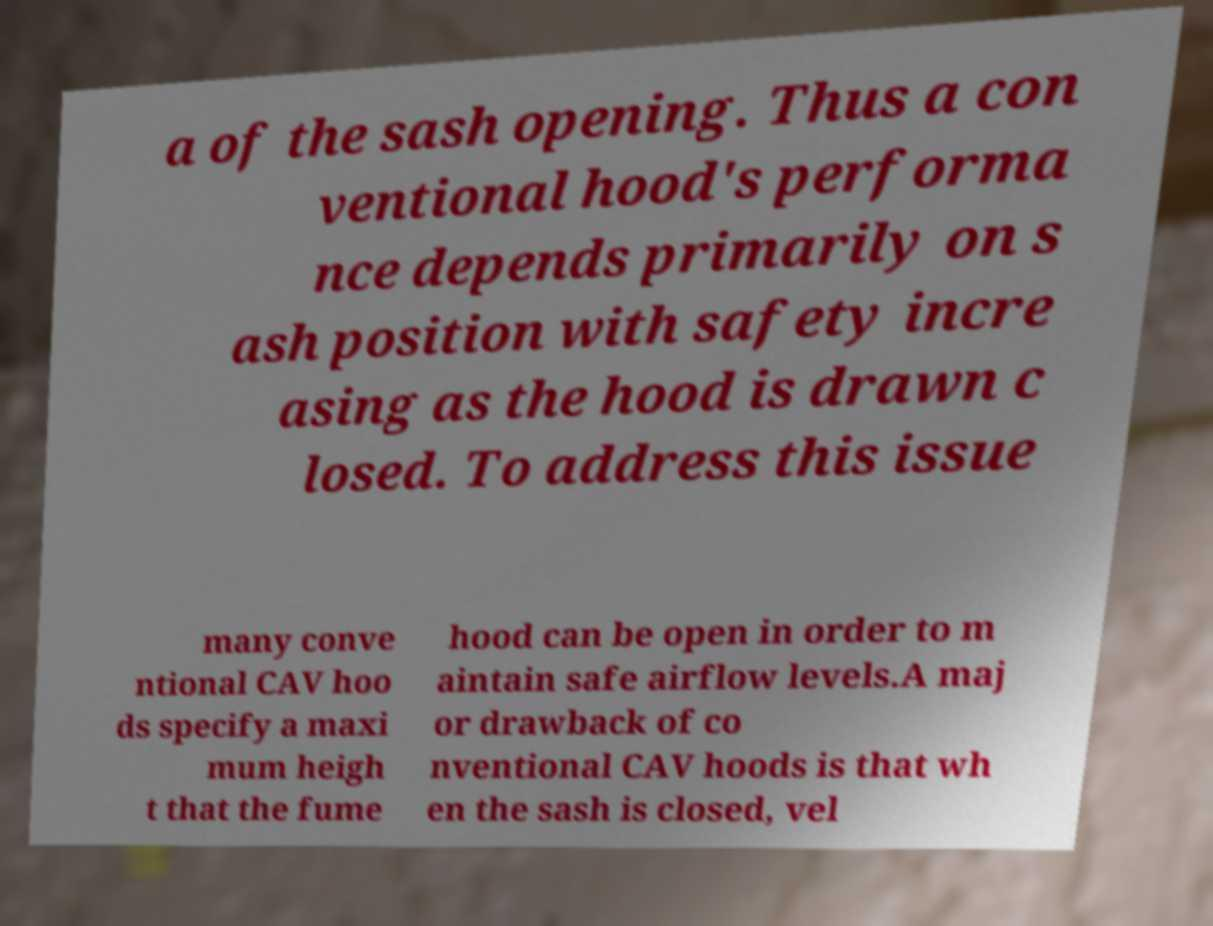What messages or text are displayed in this image? I need them in a readable, typed format. a of the sash opening. Thus a con ventional hood's performa nce depends primarily on s ash position with safety incre asing as the hood is drawn c losed. To address this issue many conve ntional CAV hoo ds specify a maxi mum heigh t that the fume hood can be open in order to m aintain safe airflow levels.A maj or drawback of co nventional CAV hoods is that wh en the sash is closed, vel 